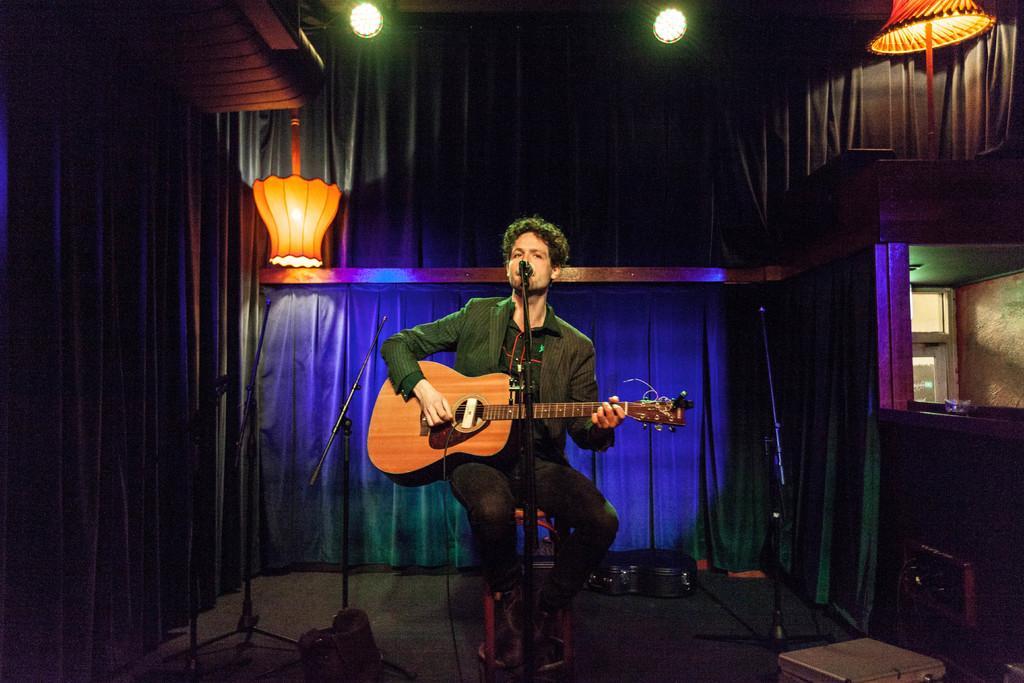Please provide a concise description of this image. A man is singing with a mic in front of him while playing guitar on a stage. 